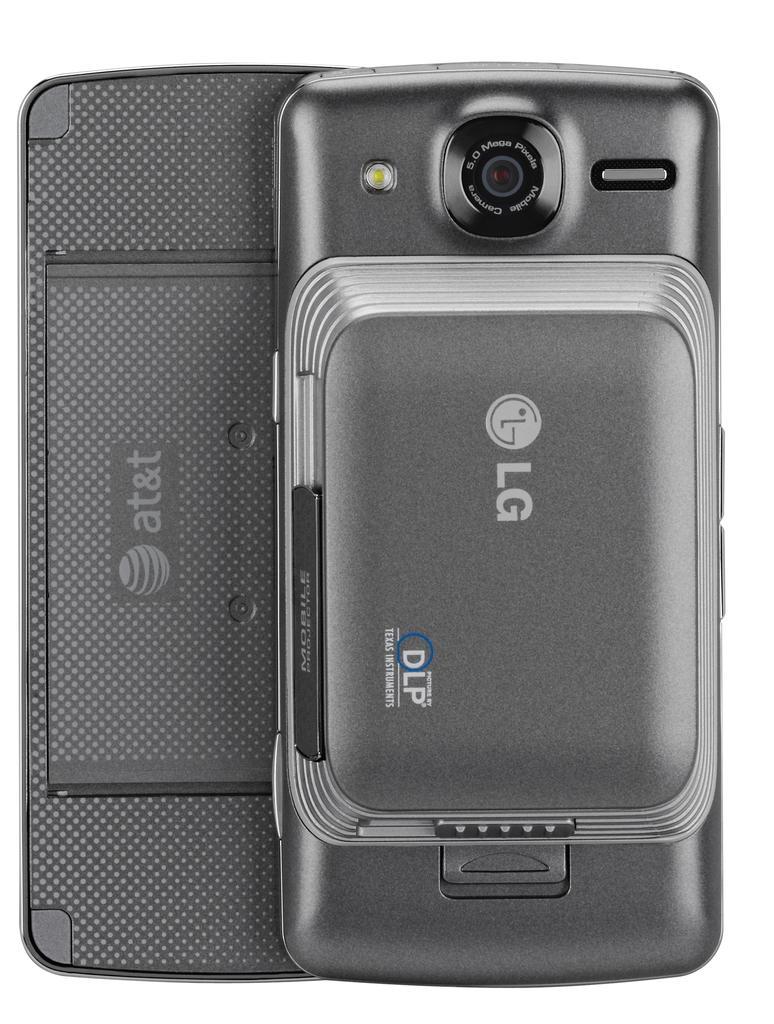Please provide a concise description of this image. In this image we can see a cell phone which is placed on the surface. 